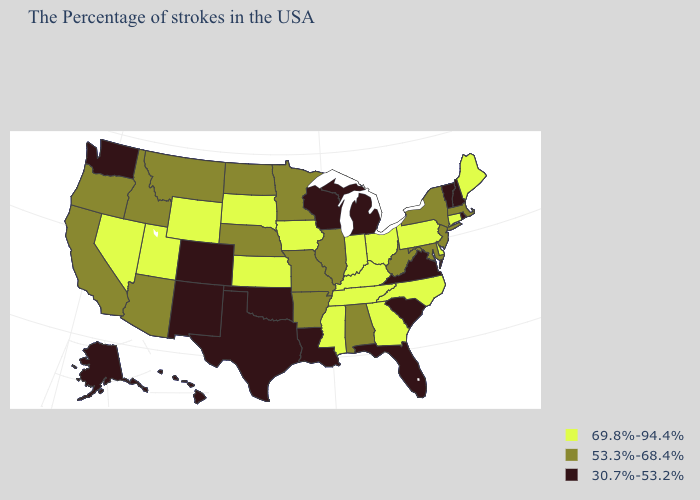What is the value of Hawaii?
Give a very brief answer. 30.7%-53.2%. Among the states that border Vermont , which have the lowest value?
Give a very brief answer. New Hampshire. Name the states that have a value in the range 69.8%-94.4%?
Write a very short answer. Maine, Connecticut, Delaware, Pennsylvania, North Carolina, Ohio, Georgia, Kentucky, Indiana, Tennessee, Mississippi, Iowa, Kansas, South Dakota, Wyoming, Utah, Nevada. What is the value of California?
Be succinct. 53.3%-68.4%. Does the first symbol in the legend represent the smallest category?
Keep it brief. No. Name the states that have a value in the range 30.7%-53.2%?
Keep it brief. Rhode Island, New Hampshire, Vermont, Virginia, South Carolina, Florida, Michigan, Wisconsin, Louisiana, Oklahoma, Texas, Colorado, New Mexico, Washington, Alaska, Hawaii. What is the value of Texas?
Keep it brief. 30.7%-53.2%. Among the states that border Colorado , does New Mexico have the highest value?
Concise answer only. No. Does Virginia have the highest value in the USA?
Keep it brief. No. Does Pennsylvania have the same value as Indiana?
Answer briefly. Yes. How many symbols are there in the legend?
Be succinct. 3. What is the value of Pennsylvania?
Be succinct. 69.8%-94.4%. Does Tennessee have the highest value in the USA?
Give a very brief answer. Yes. Name the states that have a value in the range 69.8%-94.4%?
Write a very short answer. Maine, Connecticut, Delaware, Pennsylvania, North Carolina, Ohio, Georgia, Kentucky, Indiana, Tennessee, Mississippi, Iowa, Kansas, South Dakota, Wyoming, Utah, Nevada. Name the states that have a value in the range 69.8%-94.4%?
Be succinct. Maine, Connecticut, Delaware, Pennsylvania, North Carolina, Ohio, Georgia, Kentucky, Indiana, Tennessee, Mississippi, Iowa, Kansas, South Dakota, Wyoming, Utah, Nevada. 